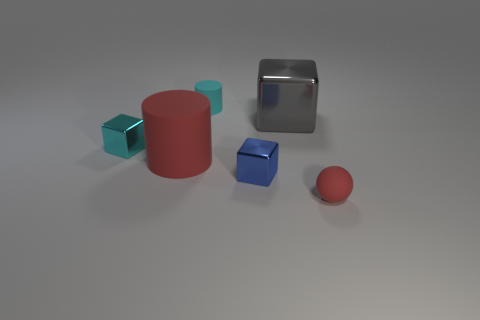Subtract all small cyan shiny blocks. How many blocks are left? 2 Add 3 large purple cylinders. How many objects exist? 9 Subtract all gray cubes. How many cubes are left? 2 Subtract all balls. How many objects are left? 5 Add 4 big red matte cylinders. How many big red matte cylinders exist? 5 Subtract 0 blue cylinders. How many objects are left? 6 Subtract 2 cubes. How many cubes are left? 1 Subtract all purple cubes. Subtract all brown balls. How many cubes are left? 3 Subtract all small cyan metallic cylinders. Subtract all tiny matte objects. How many objects are left? 4 Add 5 tiny blue metallic things. How many tiny blue metallic things are left? 6 